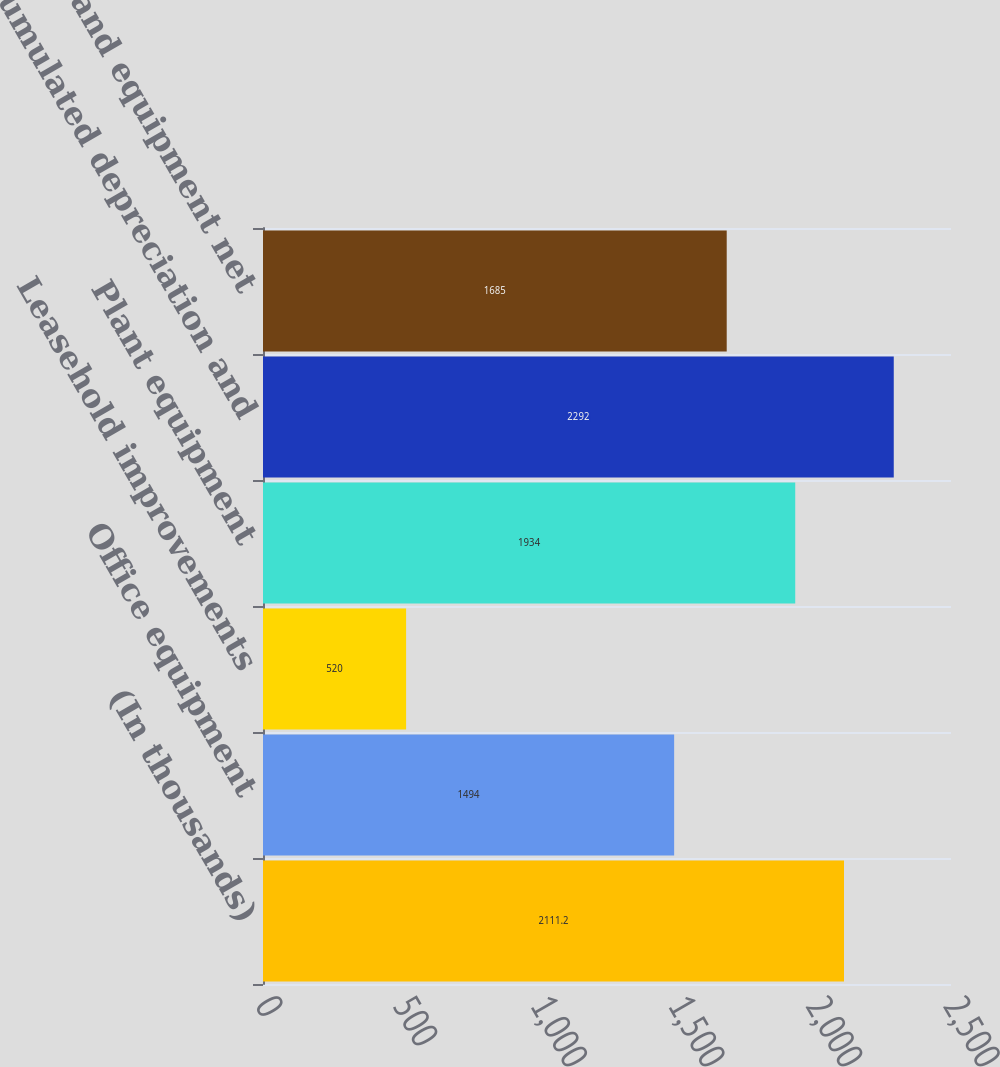Convert chart. <chart><loc_0><loc_0><loc_500><loc_500><bar_chart><fcel>(In thousands)<fcel>Office equipment<fcel>Leasehold improvements<fcel>Plant equipment<fcel>Accumulated depreciation and<fcel>Property and equipment net<nl><fcel>2111.2<fcel>1494<fcel>520<fcel>1934<fcel>2292<fcel>1685<nl></chart> 